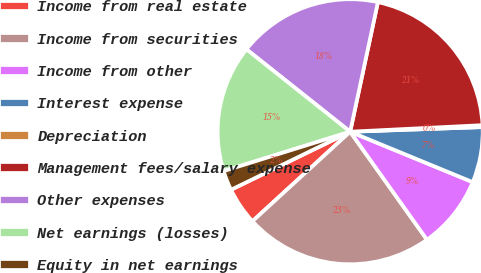Convert chart to OTSL. <chart><loc_0><loc_0><loc_500><loc_500><pie_chart><fcel>Income from real estate<fcel>Income from securities<fcel>Income from other<fcel>Interest expense<fcel>Depreciation<fcel>Management fees/salary expense<fcel>Other expenses<fcel>Net earnings (losses)<fcel>Equity in net earnings<nl><fcel>4.59%<fcel>23.04%<fcel>8.95%<fcel>6.77%<fcel>0.23%<fcel>20.86%<fcel>17.67%<fcel>15.49%<fcel>2.41%<nl></chart> 